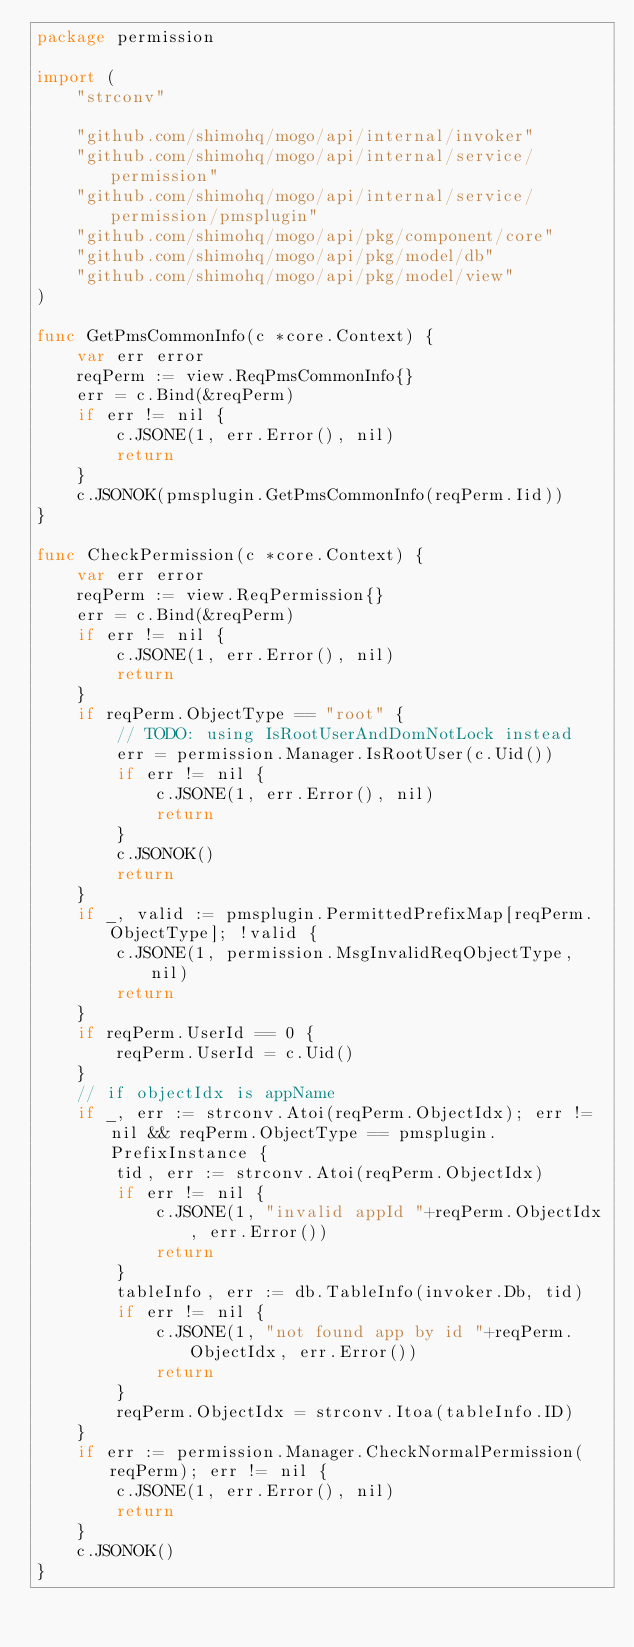<code> <loc_0><loc_0><loc_500><loc_500><_Go_>package permission

import (
	"strconv"

	"github.com/shimohq/mogo/api/internal/invoker"
	"github.com/shimohq/mogo/api/internal/service/permission"
	"github.com/shimohq/mogo/api/internal/service/permission/pmsplugin"
	"github.com/shimohq/mogo/api/pkg/component/core"
	"github.com/shimohq/mogo/api/pkg/model/db"
	"github.com/shimohq/mogo/api/pkg/model/view"
)

func GetPmsCommonInfo(c *core.Context) {
	var err error
	reqPerm := view.ReqPmsCommonInfo{}
	err = c.Bind(&reqPerm)
	if err != nil {
		c.JSONE(1, err.Error(), nil)
		return
	}
	c.JSONOK(pmsplugin.GetPmsCommonInfo(reqPerm.Iid))
}

func CheckPermission(c *core.Context) {
	var err error
	reqPerm := view.ReqPermission{}
	err = c.Bind(&reqPerm)
	if err != nil {
		c.JSONE(1, err.Error(), nil)
		return
	}
	if reqPerm.ObjectType == "root" {
		// TODO: using IsRootUserAndDomNotLock instead
		err = permission.Manager.IsRootUser(c.Uid())
		if err != nil {
			c.JSONE(1, err.Error(), nil)
			return
		}
		c.JSONOK()
		return
	}
	if _, valid := pmsplugin.PermittedPrefixMap[reqPerm.ObjectType]; !valid {
		c.JSONE(1, permission.MsgInvalidReqObjectType, nil)
		return
	}
	if reqPerm.UserId == 0 {
		reqPerm.UserId = c.Uid()
	}
	// if objectIdx is appName
	if _, err := strconv.Atoi(reqPerm.ObjectIdx); err != nil && reqPerm.ObjectType == pmsplugin.PrefixInstance {
		tid, err := strconv.Atoi(reqPerm.ObjectIdx)
		if err != nil {
			c.JSONE(1, "invalid appId "+reqPerm.ObjectIdx, err.Error())
			return
		}
		tableInfo, err := db.TableInfo(invoker.Db, tid)
		if err != nil {
			c.JSONE(1, "not found app by id "+reqPerm.ObjectIdx, err.Error())
			return
		}
		reqPerm.ObjectIdx = strconv.Itoa(tableInfo.ID)
	}
	if err := permission.Manager.CheckNormalPermission(reqPerm); err != nil {
		c.JSONE(1, err.Error(), nil)
		return
	}
	c.JSONOK()
}
</code> 